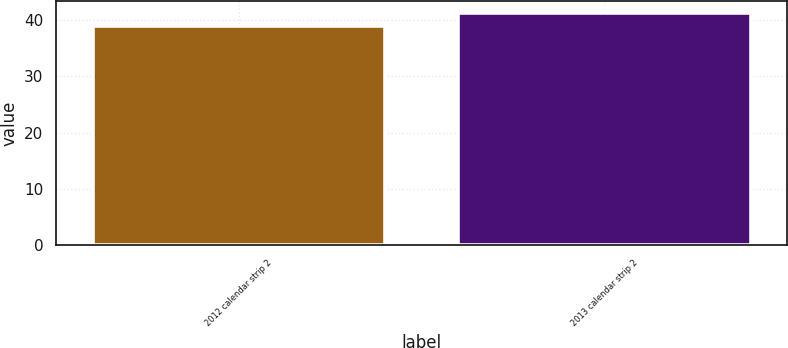Convert chart. <chart><loc_0><loc_0><loc_500><loc_500><bar_chart><fcel>2012 calendar strip 2<fcel>2013 calendar strip 2<nl><fcel>38.85<fcel>41.26<nl></chart> 